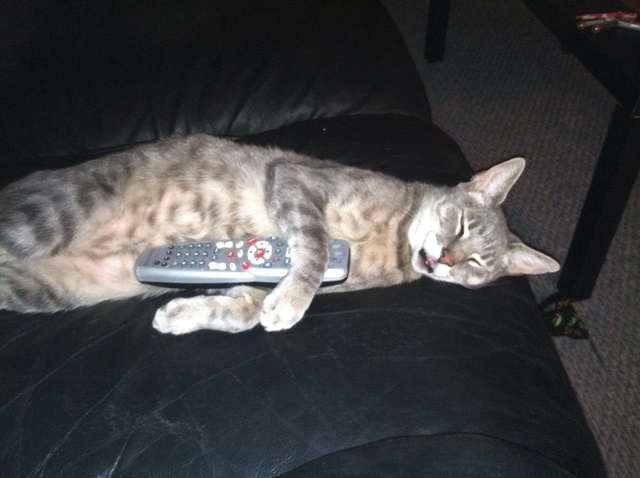Describe the objects in this image and their specific colors. I can see bed in black, darkblue, and gray tones, cat in black, darkgray, lightgray, gray, and tan tones, couch in black and gray tones, and remote in black, darkgray, white, and gray tones in this image. 